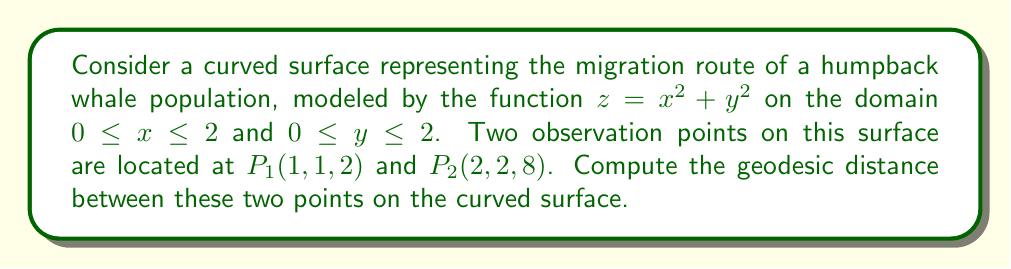What is the answer to this math problem? To solve this problem, we'll follow these steps:

1) First, we need to compute the metric tensor for the surface. The surface is given by $z = f(x,y) = x^2 + y^2$. The metric tensor is given by:

   $$g_{ij} = \begin{pmatrix}
   1 + (\frac{\partial f}{\partial x})^2 & \frac{\partial f}{\partial x}\frac{\partial f}{\partial y} \\
   \frac{\partial f}{\partial x}\frac{\partial f}{\partial y} & 1 + (\frac{\partial f}{\partial y})^2
   \end{pmatrix}$$

2) We calculate the partial derivatives:
   $\frac{\partial f}{\partial x} = 2x$ and $\frac{\partial f}{\partial y} = 2y$

3) Substituting into the metric tensor:

   $$g_{ij} = \begin{pmatrix}
   1 + 4x^2 & 4xy \\
   4xy & 1 + 4y^2
   \end{pmatrix}$$

4) The geodesic equation is given by:

   $$\frac{d^2x^i}{dt^2} + \Gamma^i_{jk}\frac{dx^j}{dt}\frac{dx^k}{dt} = 0$$

   where $\Gamma^i_{jk}$ are the Christoffel symbols.

5) Solving this differential equation analytically is complex. For practical purposes, we can approximate the geodesic distance using numerical methods or by using the straight-line distance as an upper bound.

6) The straight-line distance between the points is:

   $$d = \sqrt{(2-1)^2 + (2-1)^2 + (8-2)^2} = \sqrt{1 + 1 + 36} = \sqrt{38} \approx 6.16$$

7) The actual geodesic distance will be slightly longer than this straight-line distance due to the curvature of the surface.

8) For a more accurate approximation, we could use numerical methods such as the geodesic shooting method or solve the geodesic equation numerically.

Given the complexity of the exact solution and the approximation nature of many real-world measurements in zoology, the straight-line distance can serve as a reasonable lower bound for the geodesic distance in this context.
Answer: The geodesic distance between the two points is approximately 6.16 units (the straight-line distance), which serves as a lower bound. The actual geodesic distance on the curved surface will be slightly longer due to the surface curvature. 